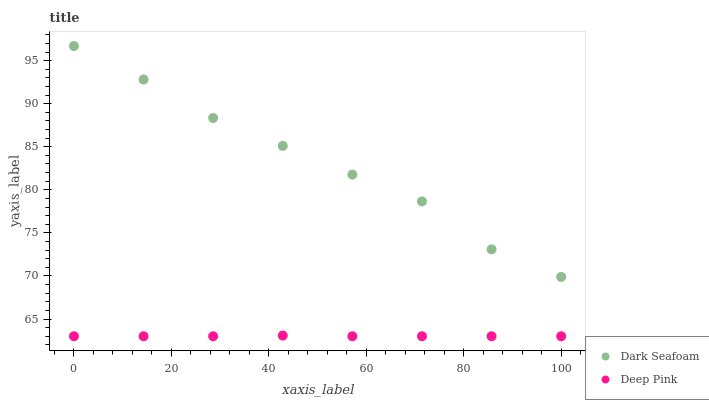Does Deep Pink have the minimum area under the curve?
Answer yes or no. Yes. Does Dark Seafoam have the maximum area under the curve?
Answer yes or no. Yes. Does Deep Pink have the maximum area under the curve?
Answer yes or no. No. Is Deep Pink the smoothest?
Answer yes or no. Yes. Is Dark Seafoam the roughest?
Answer yes or no. Yes. Is Deep Pink the roughest?
Answer yes or no. No. Does Deep Pink have the lowest value?
Answer yes or no. Yes. Does Dark Seafoam have the highest value?
Answer yes or no. Yes. Does Deep Pink have the highest value?
Answer yes or no. No. Is Deep Pink less than Dark Seafoam?
Answer yes or no. Yes. Is Dark Seafoam greater than Deep Pink?
Answer yes or no. Yes. Does Deep Pink intersect Dark Seafoam?
Answer yes or no. No. 